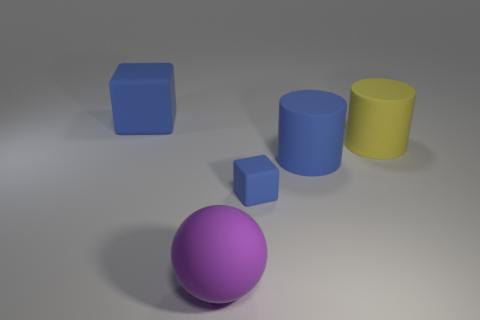Add 1 tiny blocks. How many objects exist? 6 Subtract all balls. How many objects are left? 4 Add 1 tiny brown things. How many tiny brown things exist? 1 Subtract 0 yellow blocks. How many objects are left? 5 Subtract all big matte cylinders. Subtract all big blue rubber cylinders. How many objects are left? 2 Add 1 blue cylinders. How many blue cylinders are left? 2 